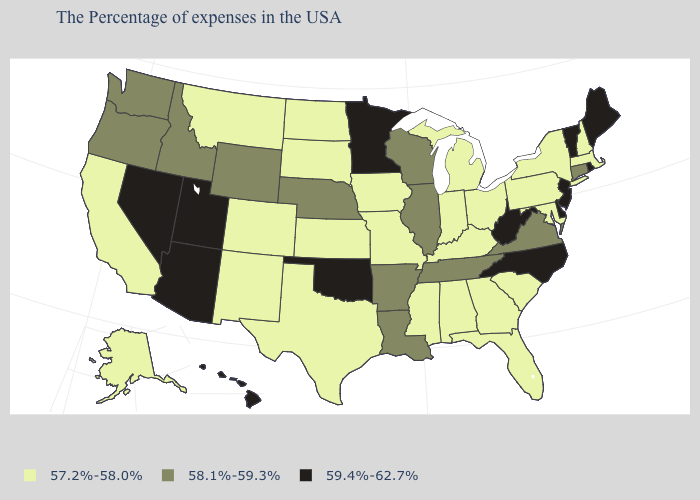Name the states that have a value in the range 57.2%-58.0%?
Concise answer only. Massachusetts, New Hampshire, New York, Maryland, Pennsylvania, South Carolina, Ohio, Florida, Georgia, Michigan, Kentucky, Indiana, Alabama, Mississippi, Missouri, Iowa, Kansas, Texas, South Dakota, North Dakota, Colorado, New Mexico, Montana, California, Alaska. Name the states that have a value in the range 59.4%-62.7%?
Give a very brief answer. Maine, Rhode Island, Vermont, New Jersey, Delaware, North Carolina, West Virginia, Minnesota, Oklahoma, Utah, Arizona, Nevada, Hawaii. What is the value of Delaware?
Concise answer only. 59.4%-62.7%. What is the value of North Carolina?
Concise answer only. 59.4%-62.7%. Does North Dakota have the highest value in the MidWest?
Be succinct. No. Does Tennessee have the highest value in the USA?
Write a very short answer. No. How many symbols are there in the legend?
Write a very short answer. 3. Does North Dakota have the same value as Connecticut?
Quick response, please. No. What is the value of Georgia?
Short answer required. 57.2%-58.0%. Which states have the lowest value in the South?
Be succinct. Maryland, South Carolina, Florida, Georgia, Kentucky, Alabama, Mississippi, Texas. Among the states that border Wyoming , which have the lowest value?
Keep it brief. South Dakota, Colorado, Montana. What is the value of New Jersey?
Answer briefly. 59.4%-62.7%. Which states have the highest value in the USA?
Short answer required. Maine, Rhode Island, Vermont, New Jersey, Delaware, North Carolina, West Virginia, Minnesota, Oklahoma, Utah, Arizona, Nevada, Hawaii. Name the states that have a value in the range 58.1%-59.3%?
Keep it brief. Connecticut, Virginia, Tennessee, Wisconsin, Illinois, Louisiana, Arkansas, Nebraska, Wyoming, Idaho, Washington, Oregon. What is the value of New York?
Give a very brief answer. 57.2%-58.0%. 